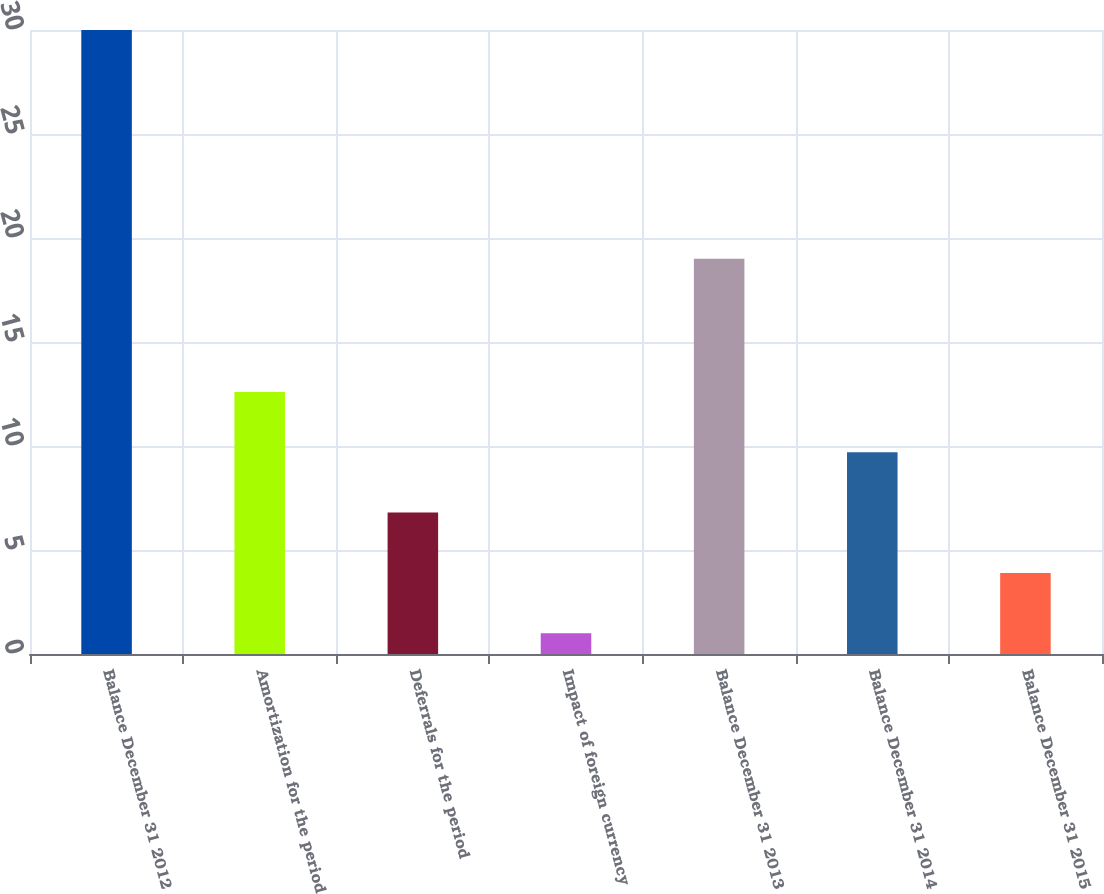Convert chart. <chart><loc_0><loc_0><loc_500><loc_500><bar_chart><fcel>Balance December 31 2012<fcel>Amortization for the period<fcel>Deferrals for the period<fcel>Impact of foreign currency<fcel>Balance December 31 2013<fcel>Balance December 31 2014<fcel>Balance December 31 2015<nl><fcel>30<fcel>12.6<fcel>6.8<fcel>1<fcel>19<fcel>9.7<fcel>3.9<nl></chart> 